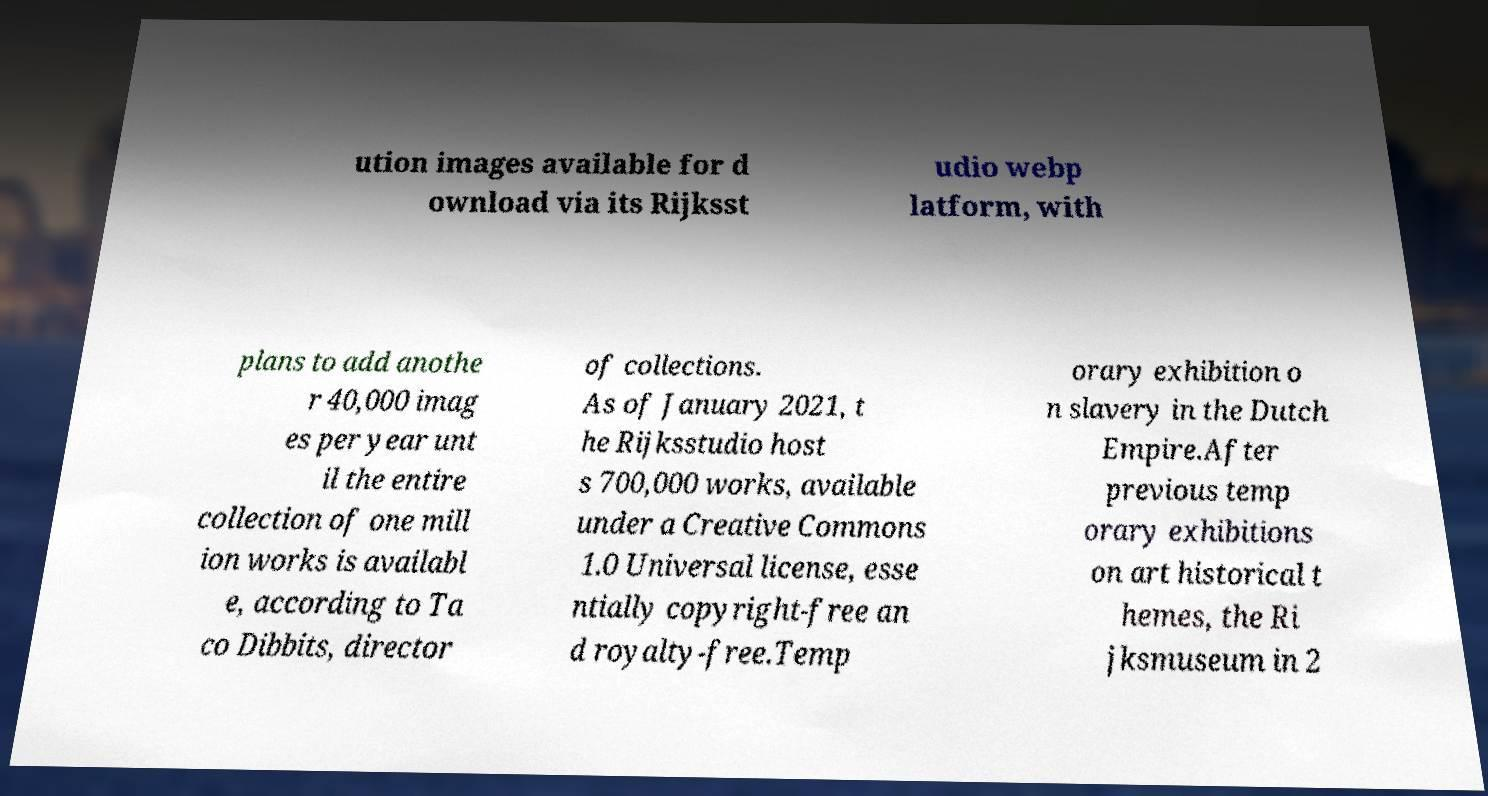Please read and relay the text visible in this image. What does it say? ution images available for d ownload via its Rijksst udio webp latform, with plans to add anothe r 40,000 imag es per year unt il the entire collection of one mill ion works is availabl e, according to Ta co Dibbits, director of collections. As of January 2021, t he Rijksstudio host s 700,000 works, available under a Creative Commons 1.0 Universal license, esse ntially copyright-free an d royalty-free.Temp orary exhibition o n slavery in the Dutch Empire.After previous temp orary exhibitions on art historical t hemes, the Ri jksmuseum in 2 